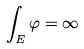Convert formula to latex. <formula><loc_0><loc_0><loc_500><loc_500>\int _ { E } \varphi = \infty</formula> 